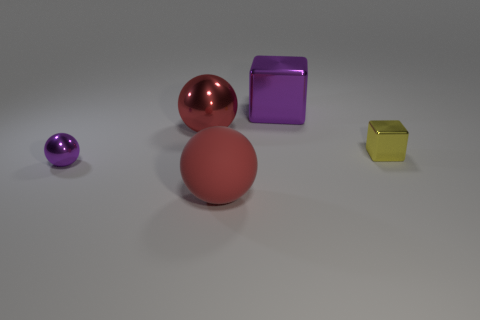There is a metallic thing that is the same color as the large rubber ball; what size is it?
Your response must be concise. Large. What material is the other big object that is the same color as the matte object?
Ensure brevity in your answer.  Metal. What is the color of the small thing that is the same shape as the large purple object?
Your answer should be compact. Yellow. What number of objects are behind the small ball and in front of the big red shiny object?
Offer a very short reply. 1. Is the number of red balls that are on the left side of the yellow shiny thing greater than the number of small balls that are behind the large cube?
Offer a terse response. Yes. The purple metal cube has what size?
Ensure brevity in your answer.  Large. Are there any rubber things that have the same shape as the yellow metallic object?
Offer a very short reply. No. There is a yellow object; is its shape the same as the metal thing behind the red shiny thing?
Provide a succinct answer. Yes. How big is the metallic object that is both on the right side of the tiny purple shiny ball and to the left of the big purple metal object?
Provide a short and direct response. Large. How many tiny purple metallic balls are there?
Your response must be concise. 1. 